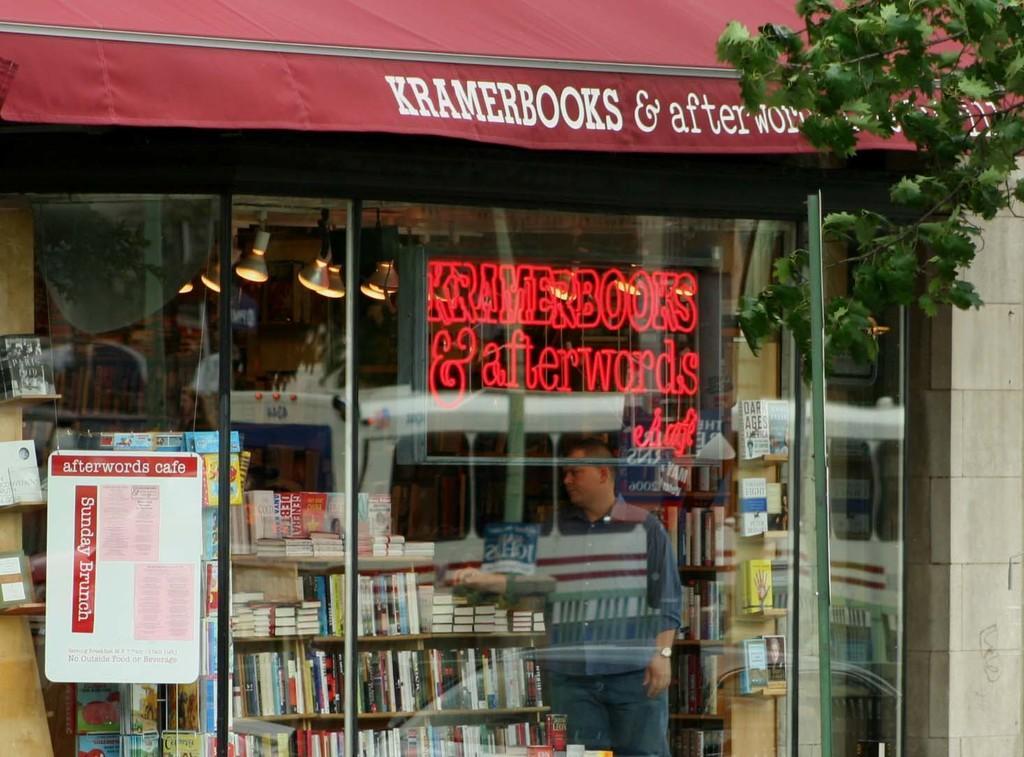Can you describe this image briefly? In this image there is a shop having a glass wall. There is a poster attached to the glass wall. Behind the glass wall there is a person standing near the rack having few books. Few lights are attached to the roof. Left side there are few shelves having few objects in it. Right side there are few branches having leaves. 